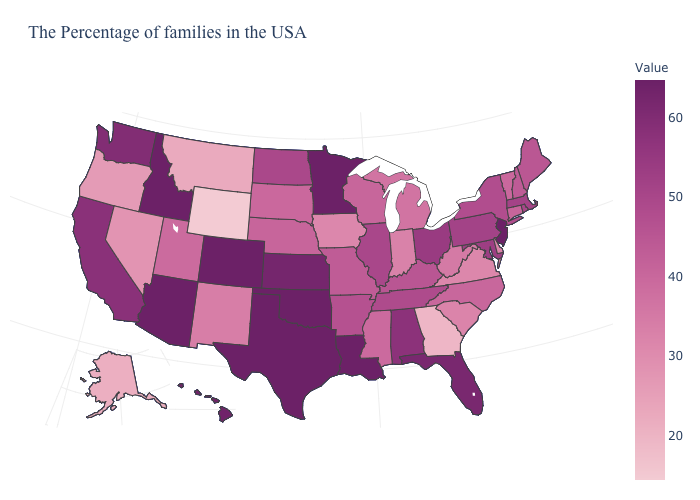Is the legend a continuous bar?
Write a very short answer. Yes. Does Rhode Island have a higher value than Wisconsin?
Keep it brief. Yes. 